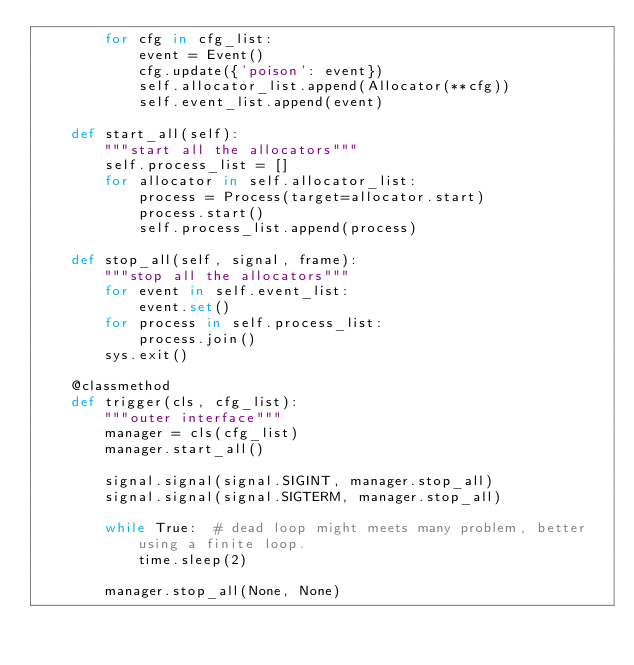Convert code to text. <code><loc_0><loc_0><loc_500><loc_500><_Python_>        for cfg in cfg_list:
            event = Event()
            cfg.update({'poison': event})
            self.allocator_list.append(Allocator(**cfg))
            self.event_list.append(event)

    def start_all(self):
        """start all the allocators"""
        self.process_list = []
        for allocator in self.allocator_list:
            process = Process(target=allocator.start)
            process.start()
            self.process_list.append(process)

    def stop_all(self, signal, frame):
        """stop all the allocators"""
        for event in self.event_list:
            event.set()
        for process in self.process_list:
            process.join()
        sys.exit()

    @classmethod
    def trigger(cls, cfg_list):
        """outer interface"""
        manager = cls(cfg_list)
        manager.start_all()

        signal.signal(signal.SIGINT, manager.stop_all)
        signal.signal(signal.SIGTERM, manager.stop_all)

        while True:  # dead loop might meets many problem, better using a finite loop.
            time.sleep(2)

        manager.stop_all(None, None)
</code> 